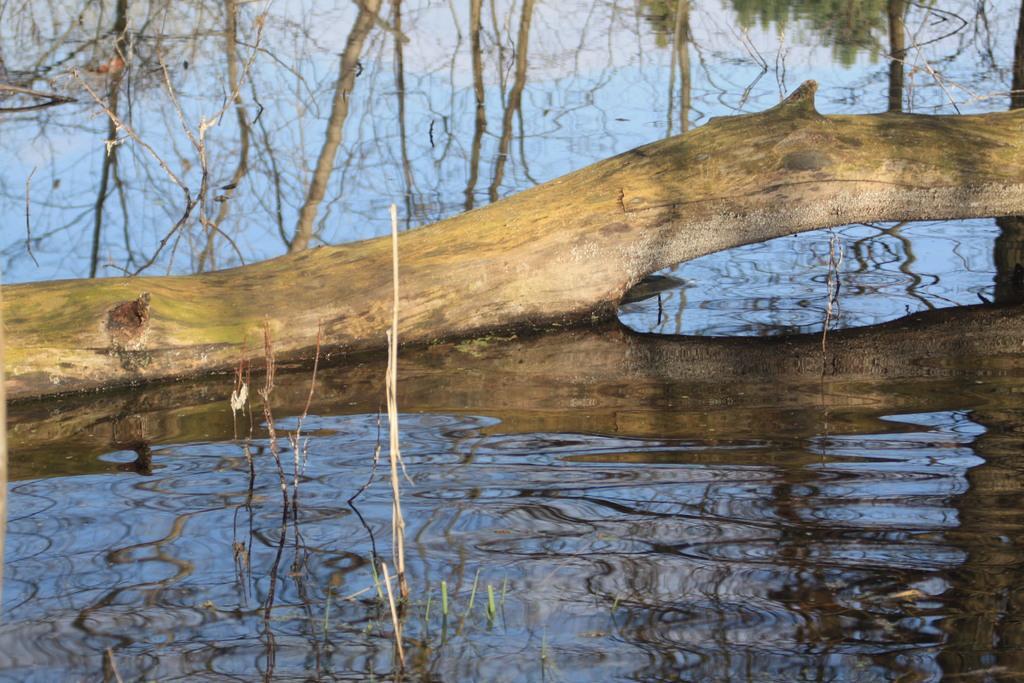Can you describe this image briefly? In this image there is a wooden branch in the water and we can see some reflections of trees in the water. 